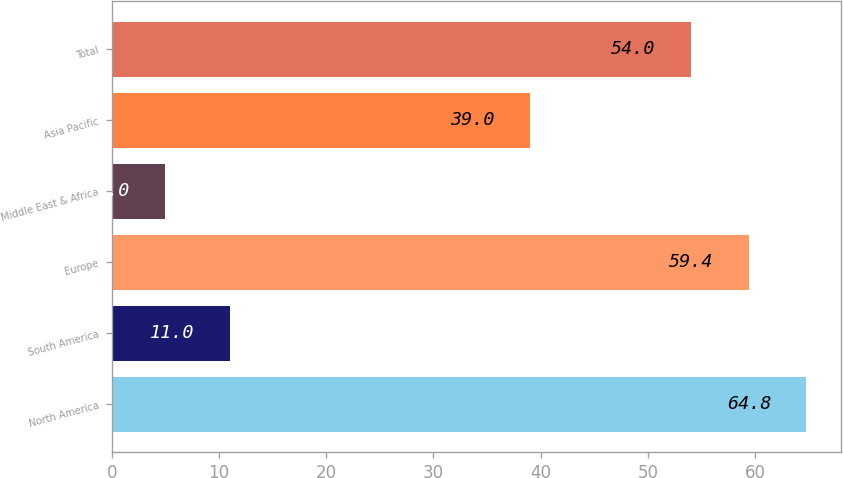Convert chart. <chart><loc_0><loc_0><loc_500><loc_500><bar_chart><fcel>North America<fcel>South America<fcel>Europe<fcel>Middle East & Africa<fcel>Asia Pacific<fcel>Total<nl><fcel>64.8<fcel>11<fcel>59.4<fcel>5<fcel>39<fcel>54<nl></chart> 